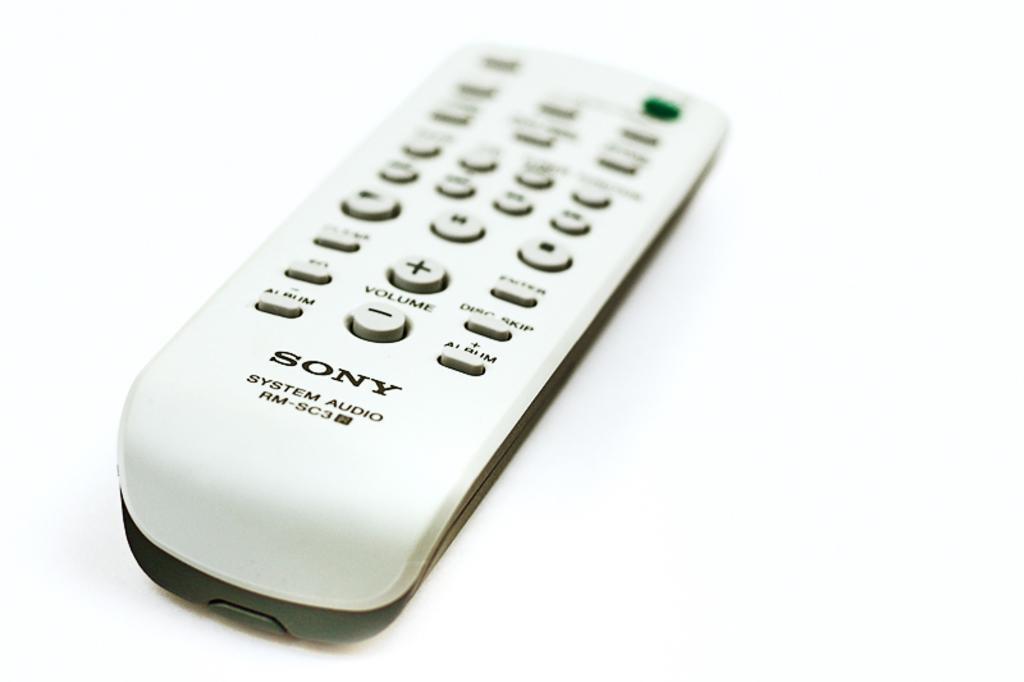<image>
Write a terse but informative summary of the picture. Sony System Audio RM-SC3 white and black remote. 